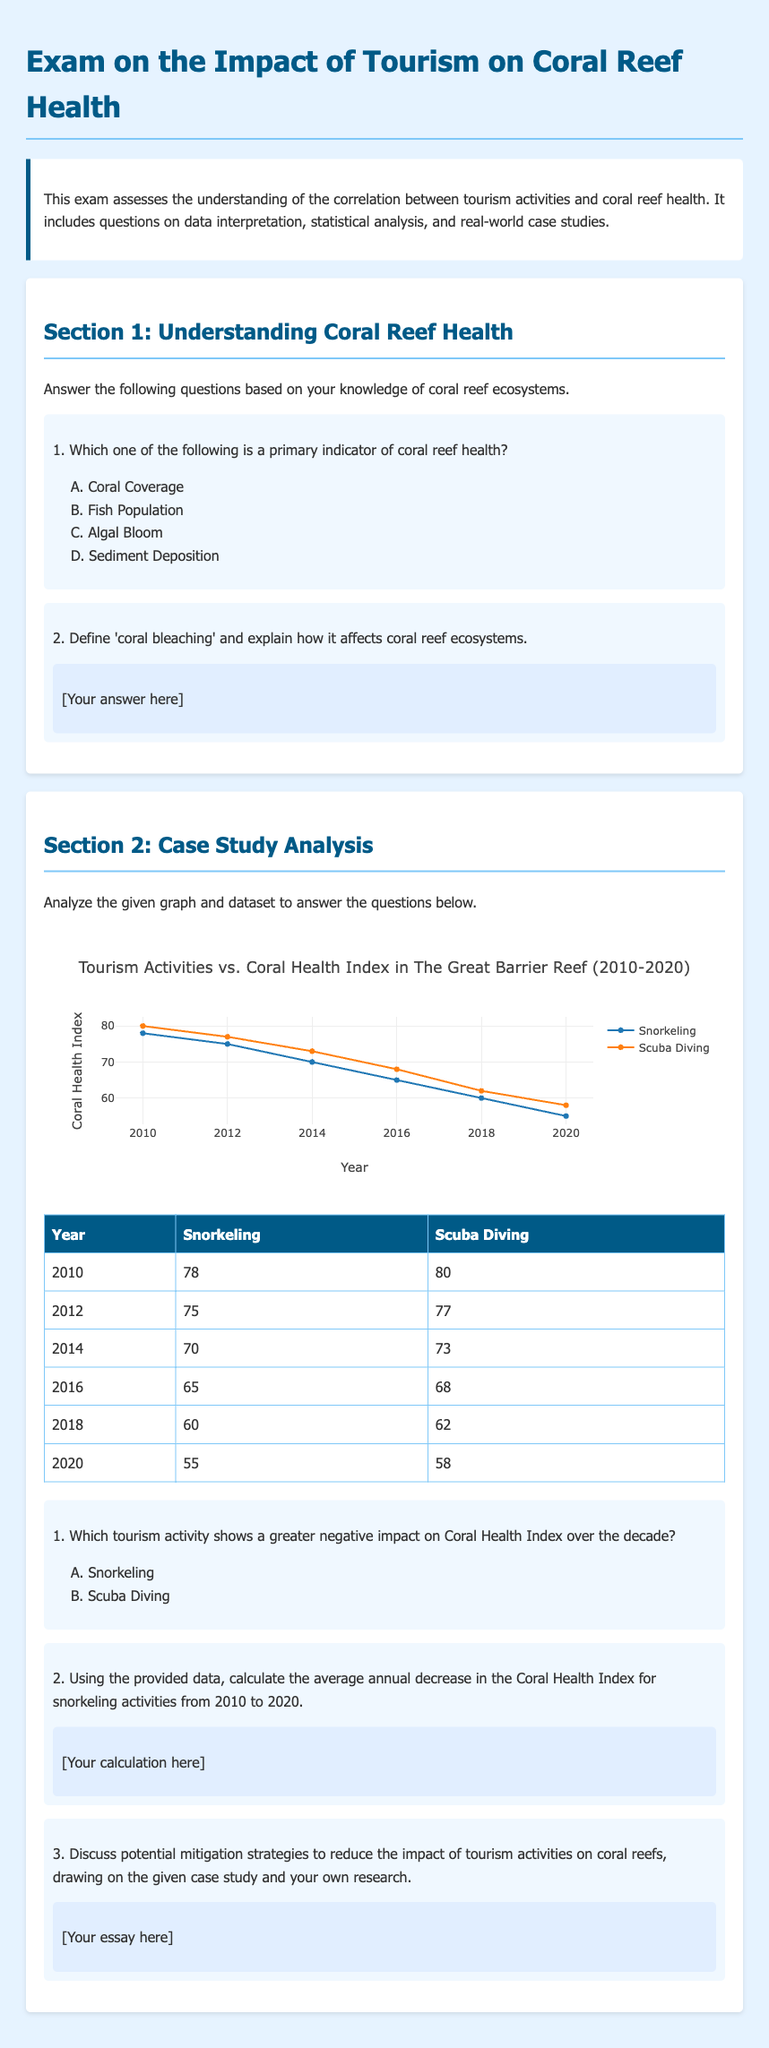What is the title of the exam? The title is found at the top of the document, stating the main topic assessed.
Answer: Exam on the Impact of Tourism on Coral Reef Health What year shows the highest Coral Health Index for snorkeling? The highest Coral Health Index for snorkeling can be identified from the table showing the years and corresponding values.
Answer: 78 What is the Coral Health Index for scuba diving in 2020? The Coral Health Index for scuba diving in 2020 is presented in the table format, which lists the index for each year.
Answer: 58 Which tourism activity had a score of 70 in 2014? The activity corresponding to the score of 70 is collected from the data table.
Answer: Snorkeling What is the total decrease in Coral Health Index for snorkeling from 2010 to 2020? The total decrease is found by subtracting the value in 2020 from the value in 2010, both specified in the data.
Answer: 23 What statistical analysis method is suggested for comparing the impacts of the two activities? The method is implied in the exam format that involves analyzing the provided dataset and visual information.
Answer: Comparative analysis What type of questions follow the case study analysis section? The nature of the questions following the case study analysis section guides the respondent on the expected answers.
Answer: Short-answer questions How many years are represented in the dataset? The dataset covers a range of years that can be counted from the provided information.
Answer: 6 Which tourism activity shows a greater negative impact on the Coral Health Index? The comparison is drawn from the data trends visible in the plotted graph and table from the document.
Answer: Snorkeling 